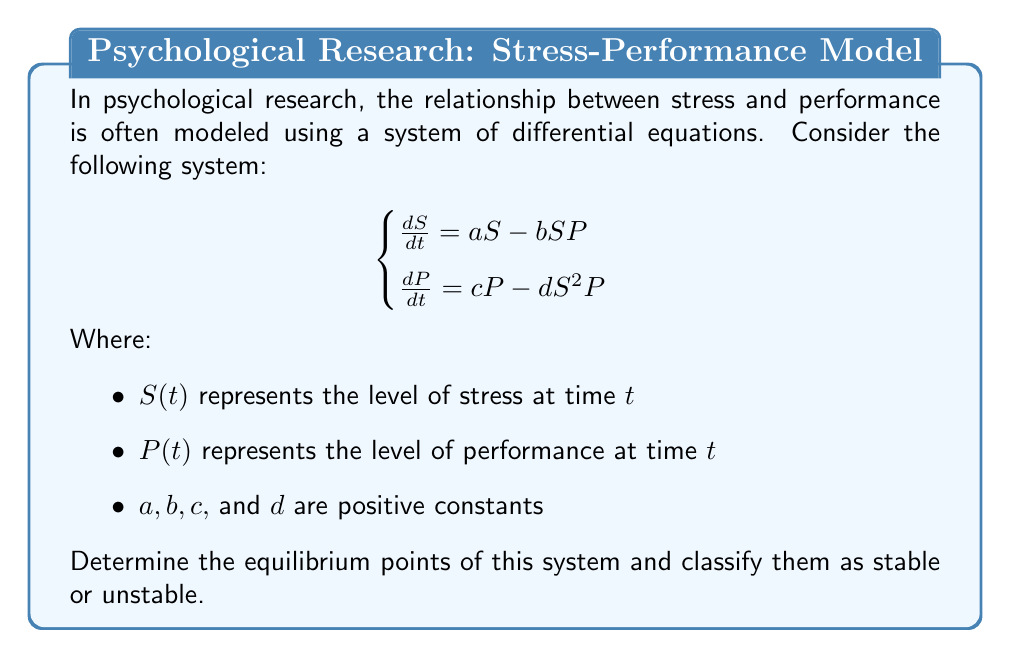Teach me how to tackle this problem. To solve this problem, we'll follow these steps:

1) Find the equilibrium points by setting both equations equal to zero:

   $$\begin{cases}
   aS - bSP = 0 \\
   cP - dS^2P = 0
   \end{cases}$$

2) From the first equation:
   $S(a - bP) = 0$
   This gives us two possibilities: $S = 0$ or $P = \frac{a}{b}$

3) From the second equation:
   $P(c - dS^2) = 0$
   This gives us two possibilities: $P = 0$ or $S = \sqrt{\frac{c}{d}}$

4) Combining these results, we get three equilibrium points:
   $(0, 0)$, $(0, \frac{a}{b})$, and $(\sqrt{\frac{c}{d}}, \frac{a}{b})$

5) To classify these points, we need to linearize the system around each point and find the eigenvalues of the Jacobian matrix:

   $$J = \begin{bmatrix}
   a - bP & -bS \\
   -2dSP & c - dS^2
   \end{bmatrix}$$

6) For $(0, 0)$:
   $$J_{(0,0)} = \begin{bmatrix}
   a & 0 \\
   0 & c
   \end{bmatrix}$$
   Eigenvalues: $\lambda_1 = a, \lambda_2 = c$
   Both are positive, so this is an unstable node.

7) For $(0, \frac{a}{b})$:
   $$J_{(0,\frac{a}{b})} = \begin{bmatrix}
   0 & 0 \\
   -2d\cdot0\cdot\frac{a}{b} & c
   \end{bmatrix} = \begin{bmatrix}
   0 & 0 \\
   0 & c
   \end{bmatrix}$$
   Eigenvalues: $\lambda_1 = 0, \lambda_2 = c$
   One zero and one positive, so this is an unstable point.

8) For $(\sqrt{\frac{c}{d}}, \frac{a}{b})$:
   $$J_{(\sqrt{\frac{c}{d}},\frac{a}{b})} = \begin{bmatrix}
   0 & -b\sqrt{\frac{c}{d}} \\
   -2c\frac{a}{b} & 0
   \end{bmatrix}$$
   Eigenvalues: $\lambda = \pm i\sqrt{2ac}$
   Pure imaginary eigenvalues, so this is a center (neutrally stable).
Answer: Equilibrium points: $(0, 0)$ (unstable), $(0, \frac{a}{b})$ (unstable), $(\sqrt{\frac{c}{d}}, \frac{a}{b})$ (neutrally stable). 